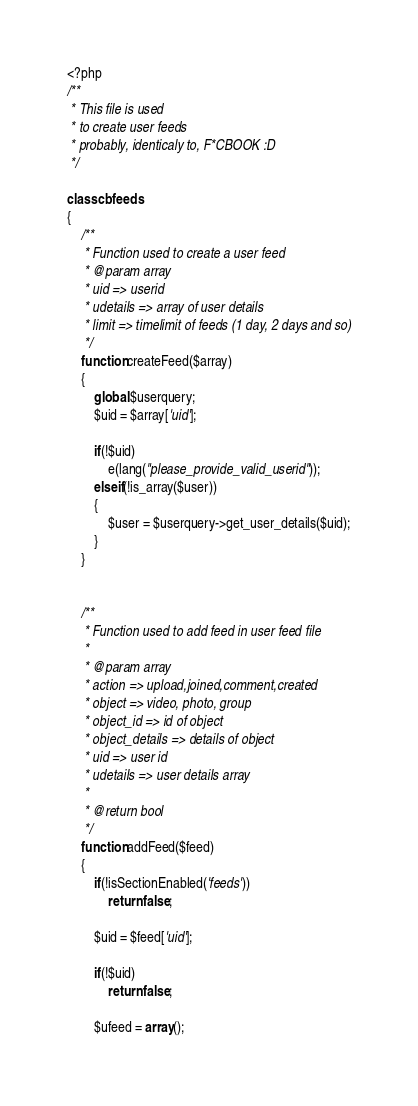Convert code to text. <code><loc_0><loc_0><loc_500><loc_500><_PHP_><?php
/**
 * This file is used
 * to create user feeds
 * probably, identicaly to, F*CBOOK :D
 */
 
class cbfeeds
{
	/**
	 * Function used to create a user feed
	 * @param array
	 * uid => userid
	 * udetails => array of user details
	 * limit => timelimit of feeds (1 day, 2 days and so)
	 */
	function createFeed($array)
	{
		global $userquery;
		$uid = $array['uid'];

		if(!$uid)
			e(lang("please_provide_valid_userid"));
		elseif(!is_array($user))
		{
			$user = $userquery->get_user_details($uid);
		}
	}


	/**
	 * Function used to add feed in user feed file
	 *
	 * @param array
	 * action => upload,joined,comment,created
	 * object => video, photo, group
	 * object_id => id of object
	 * object_details => details of object
	 * uid => user id
	 * udetails => user details array
	 *
	 * @return bool
	 */
	function addFeed($feed)
	{
		if(!isSectionEnabled('feeds'))
			return false;

		$uid = $feed['uid'];

		if(!$uid)
			return false;

		$ufeed = array();</code> 